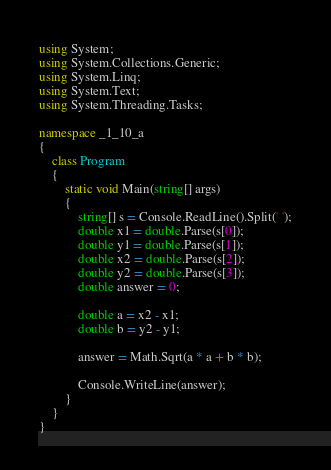<code> <loc_0><loc_0><loc_500><loc_500><_C#_>using System;
using System.Collections.Generic;
using System.Linq;
using System.Text;
using System.Threading.Tasks;

namespace _1_10_a
{
    class Program
    {
        static void Main(string[] args)
        {
            string[] s = Console.ReadLine().Split(' ');
            double x1 = double.Parse(s[0]);
            double y1 = double.Parse(s[1]);
            double x2 = double.Parse(s[2]);
            double y2 = double.Parse(s[3]);
            double answer = 0;

            double a = x2 - x1;
            double b = y2 - y1;

            answer = Math.Sqrt(a * a + b * b);

            Console.WriteLine(answer);
        }
    }
}

</code> 